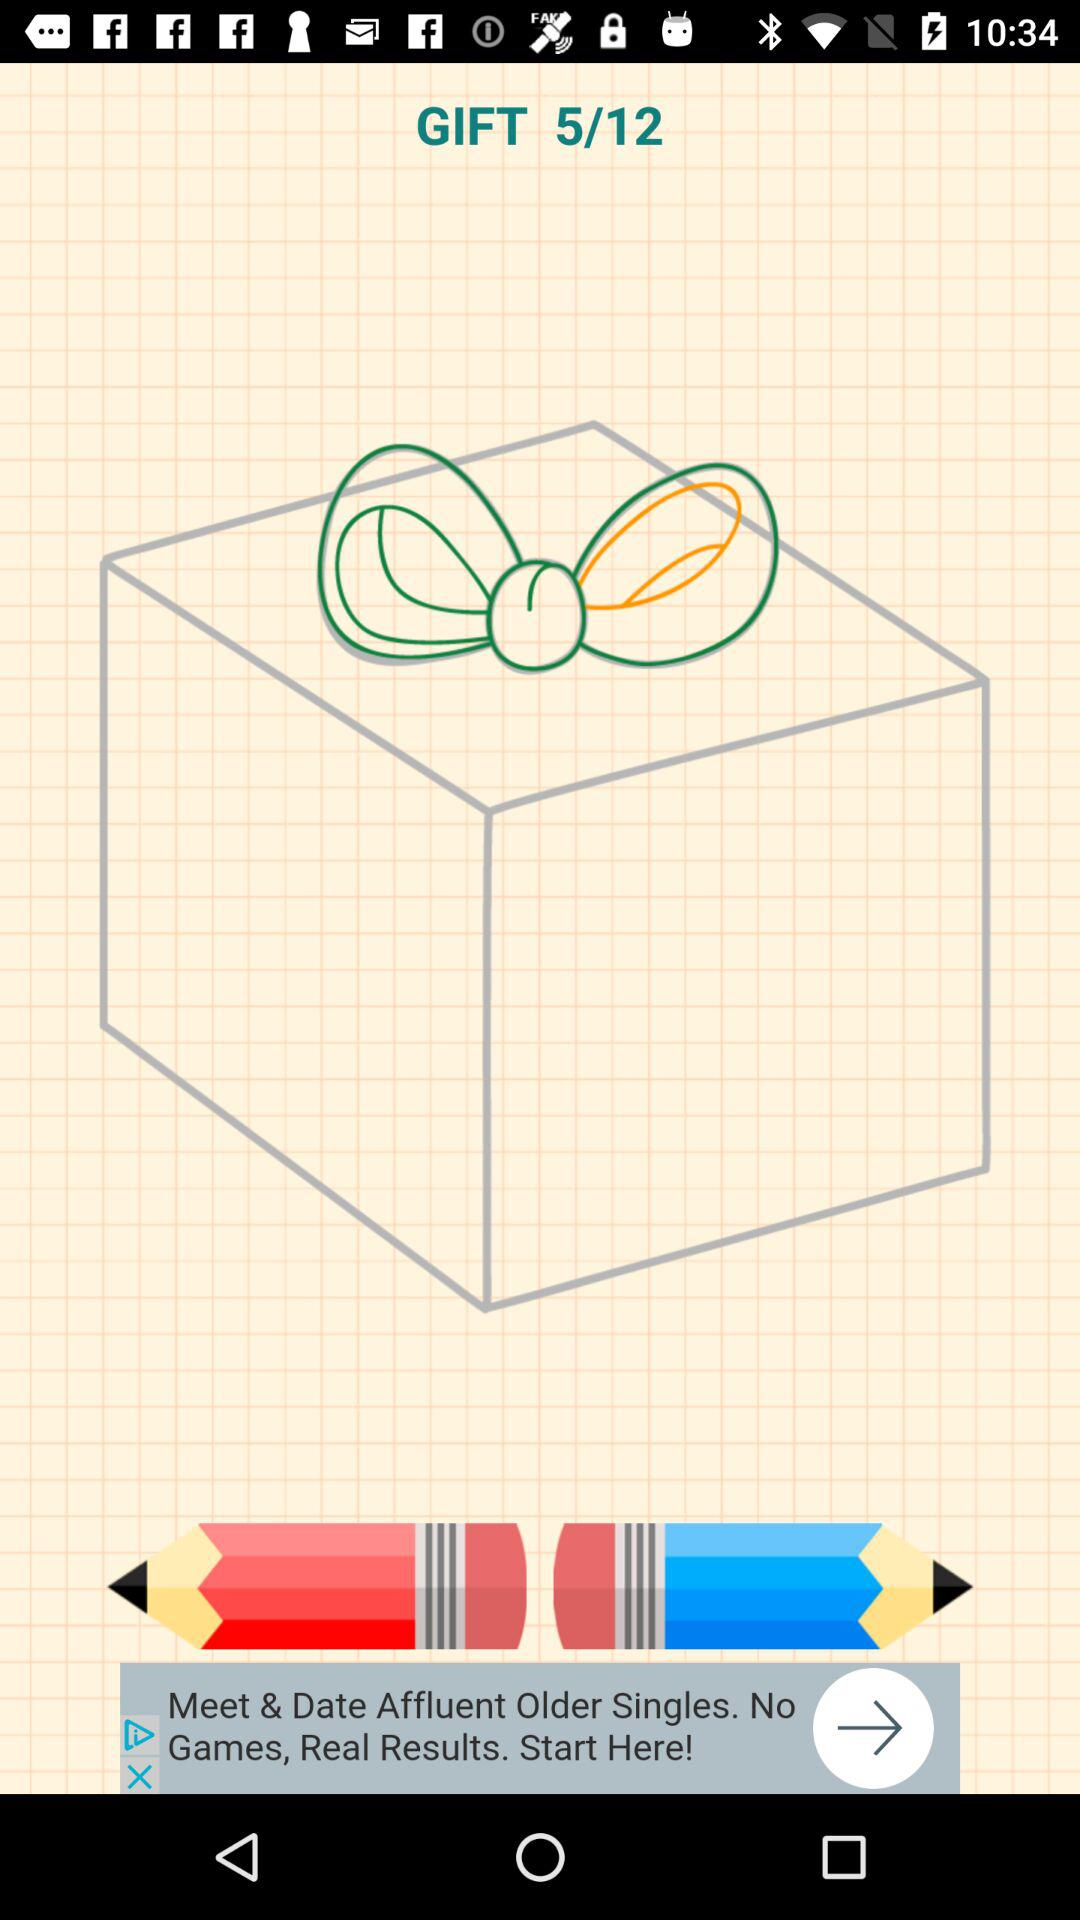How many images are there? There are 12 images. 